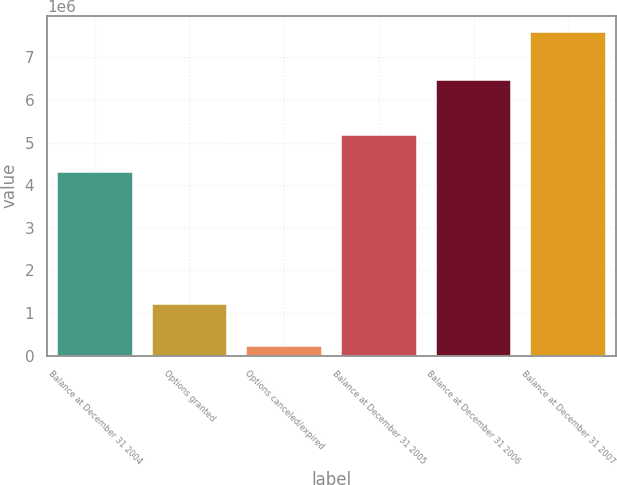Convert chart. <chart><loc_0><loc_0><loc_500><loc_500><bar_chart><fcel>Balance at December 31 2004<fcel>Options granted<fcel>Options canceled/expired<fcel>Balance at December 31 2005<fcel>Balance at December 31 2006<fcel>Balance at December 31 2007<nl><fcel>4.3198e+06<fcel>1.20096e+06<fcel>222367<fcel>5.1785e+06<fcel>6.46084e+06<fcel>7.59573e+06<nl></chart> 